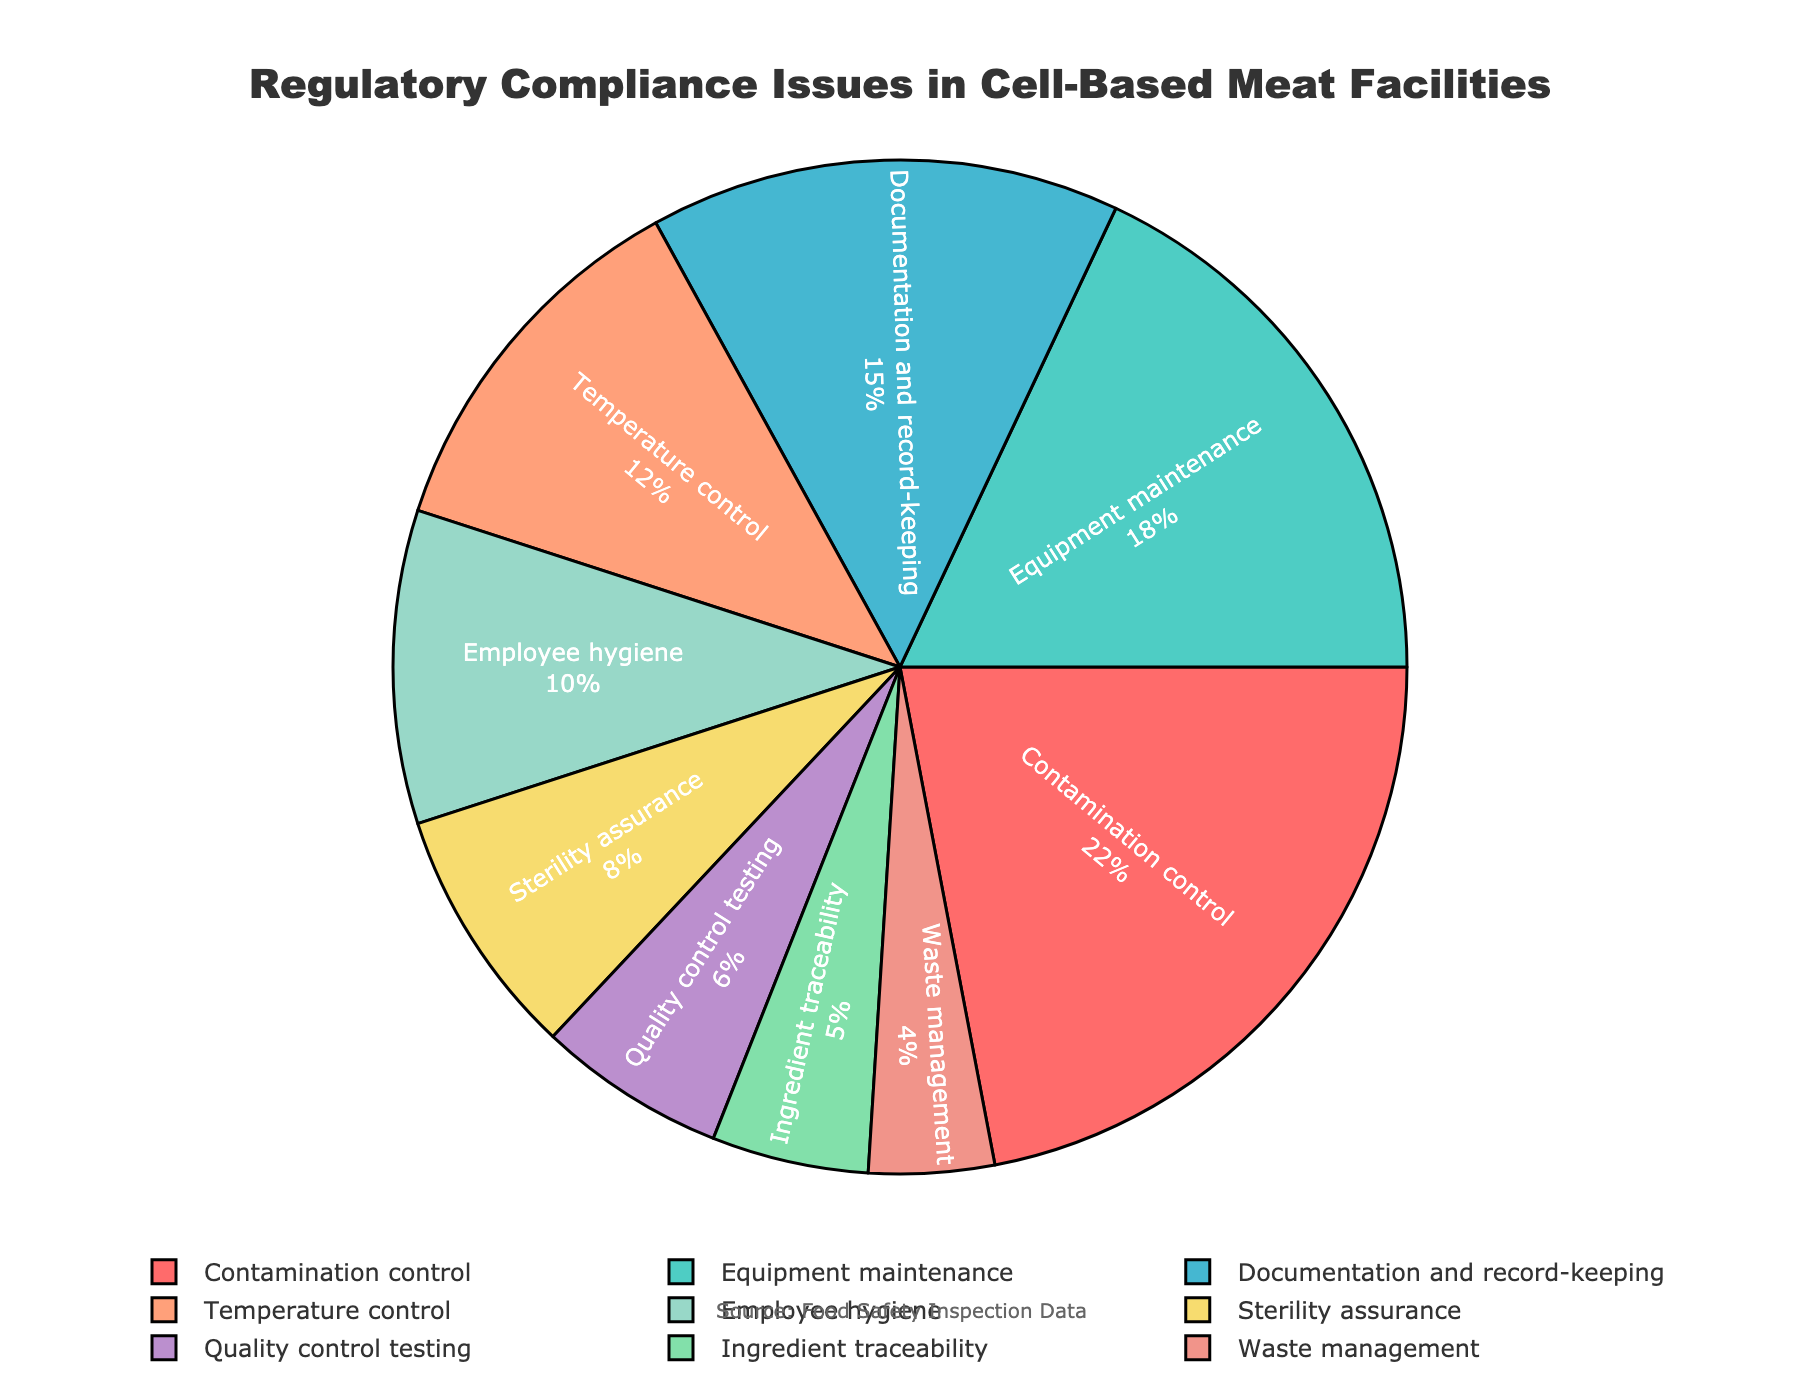What category has the highest percentage of compliance issues? The pie chart shows the largest section representing the "Contamination control" category.
Answer: Contamination control Which category has the lowest percentage of compliance issues? The smallest section in the pie chart represents the "Waste management" category.
Answer: Waste management What is the combined percentage of "Contamination control" and "Equipment maintenance"? The percentage for "Contamination control" is 22%, and for "Equipment maintenance," it is 18%. Adding them together gives 22% + 18% = 40%.
Answer: 40% Which two categories have the closest percentages of compliance issues, and what are they? "Sterility assurance" and "Quality control testing" have the closest percentages, with 8% and 6%, respectively. The difference between them is 2%.
Answer: Sterility assurance and Quality control testing Is the percentage of "Temperature control" greater than the sum of "Employee hygiene" and "Sterility assurance"? "Temperature control" is 12%. "Employee hygiene" is 10%, and "Sterility assurance" is 8%. The sum of "Employee hygiene" and "Sterility assurance" is 10% + 8% = 18%, which is greater than 12%.
Answer: No What is the average percentage value of the categories with a percentage of 10% or higher? The categories with 10% or higher are "Contamination control" (22%), "Equipment maintenance" (18%), "Documentation and record-keeping" (15%), and "Temperature control" (12%). The average is (22% + 18% + 15% + 12%) / 4 = 16.75%.
Answer: 16.75% How much larger, percentage-wise, is "Contamination control" compared to "Employee hygiene"? "Contamination control" is 22%, and "Employee hygiene" is 10%. The difference is 22% - 10% = 12%.
Answer: 12% Which color represents the "Quality control testing" category? The "Quality control testing" section of the pie chart is represented by a blue color.
Answer: Blue 